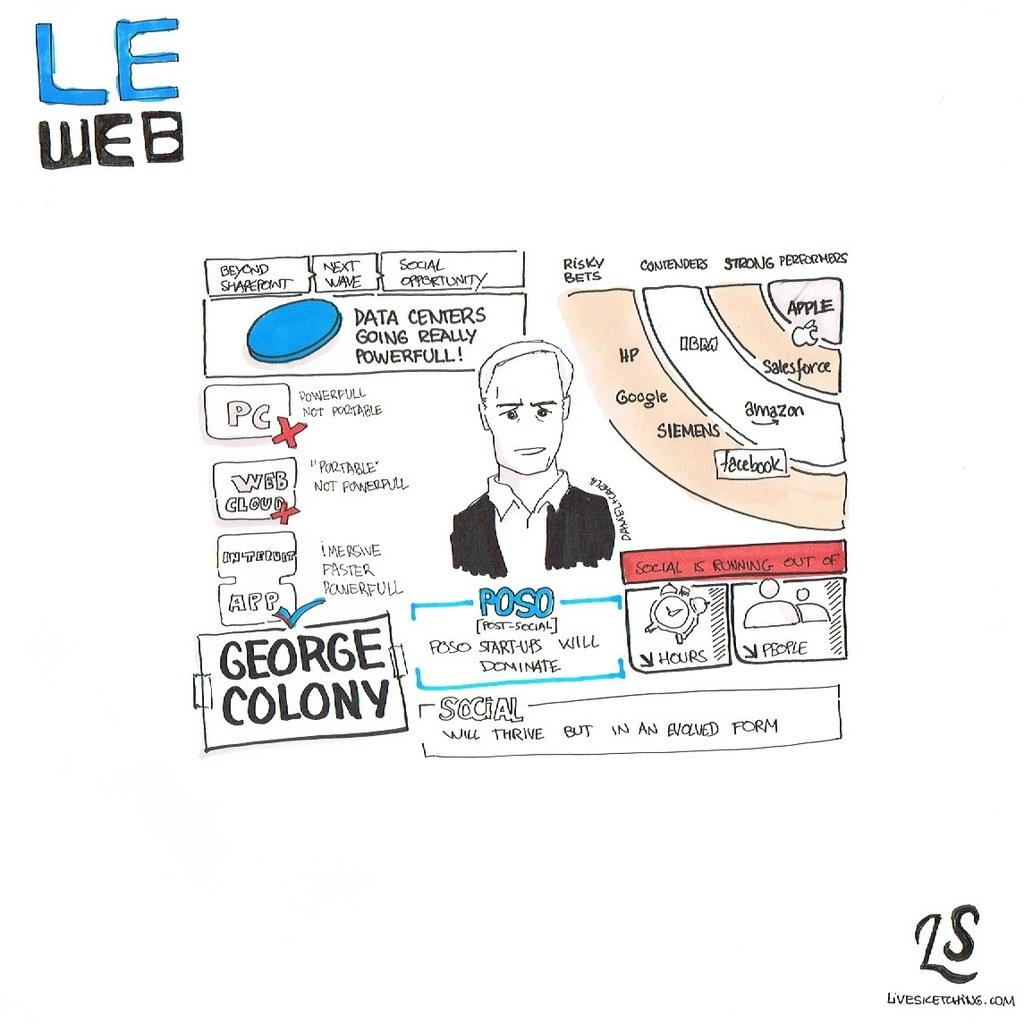What type of design element can be seen in the image? There is a logo in the image. What other design element is present in the image? There is a watermark in the image. Can you describe the person in the image? There is a man wearing a blazer and a shirt in the image. What object is present in the image that might be used for timekeeping? There is an alarm clock in the image. What type of diagrams can be seen in the image? There are flow charts in the image. What type of watch is the man wearing in the image? There is no watch visible in the image; the man is wearing a blazer and a shirt. What organization is responsible for the flow charts in the image? The image does not provide information about the organization responsible for the flow charts. 